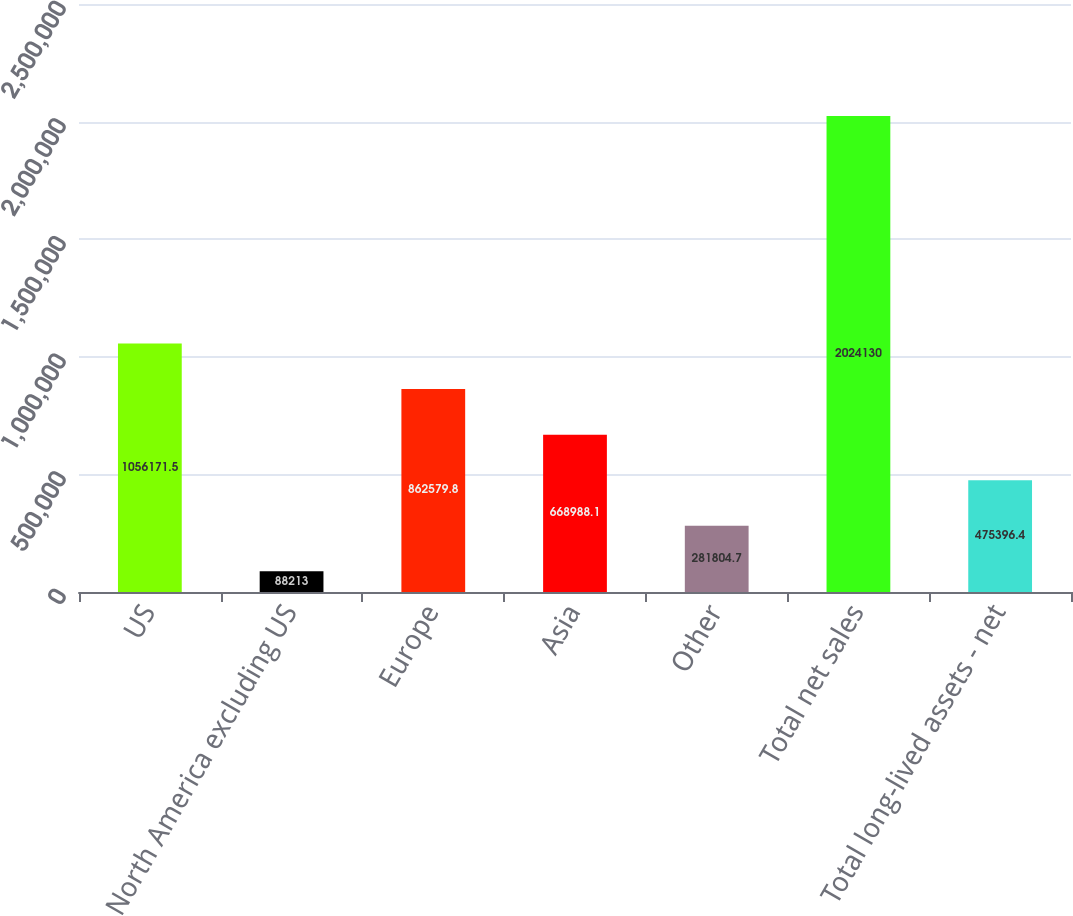Convert chart. <chart><loc_0><loc_0><loc_500><loc_500><bar_chart><fcel>US<fcel>North America excluding US<fcel>Europe<fcel>Asia<fcel>Other<fcel>Total net sales<fcel>Total long-lived assets - net<nl><fcel>1.05617e+06<fcel>88213<fcel>862580<fcel>668988<fcel>281805<fcel>2.02413e+06<fcel>475396<nl></chart> 